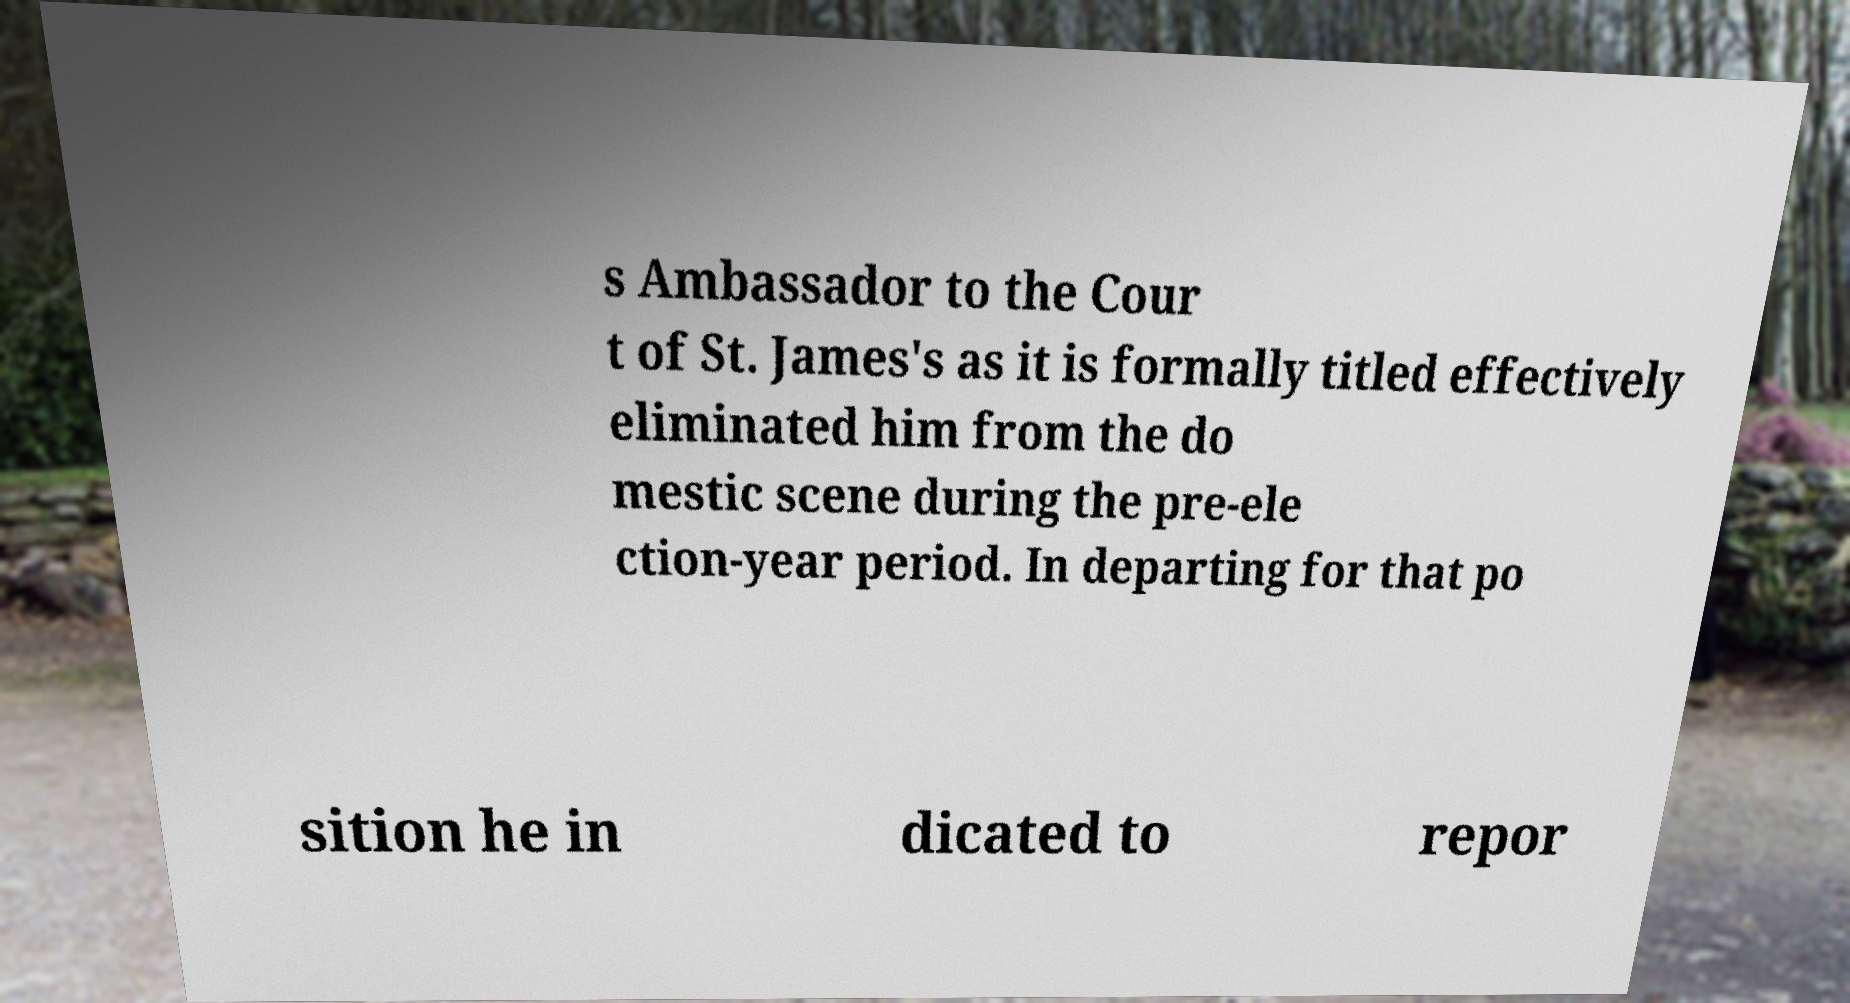Could you extract and type out the text from this image? s Ambassador to the Cour t of St. James's as it is formally titled effectively eliminated him from the do mestic scene during the pre-ele ction-year period. In departing for that po sition he in dicated to repor 